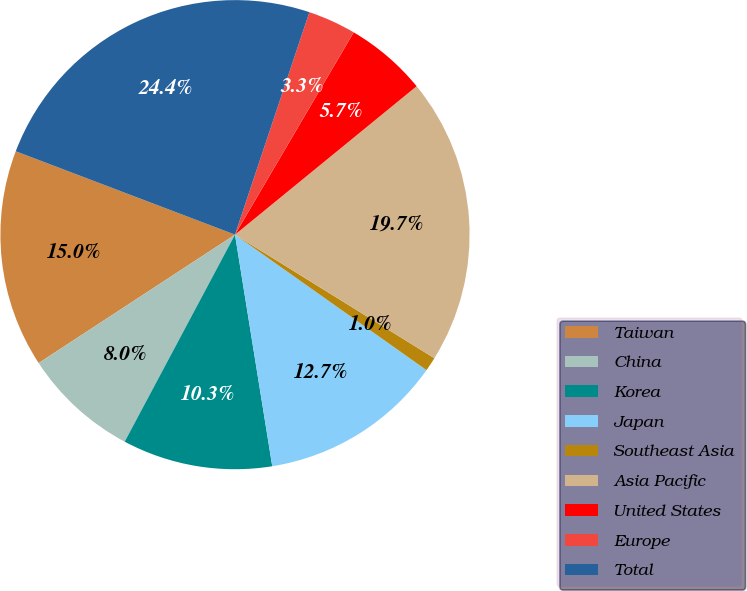Convert chart. <chart><loc_0><loc_0><loc_500><loc_500><pie_chart><fcel>Taiwan<fcel>China<fcel>Korea<fcel>Japan<fcel>Southeast Asia<fcel>Asia Pacific<fcel>United States<fcel>Europe<fcel>Total<nl><fcel>15.0%<fcel>7.99%<fcel>10.33%<fcel>12.66%<fcel>0.97%<fcel>19.73%<fcel>5.65%<fcel>3.31%<fcel>24.35%<nl></chart> 